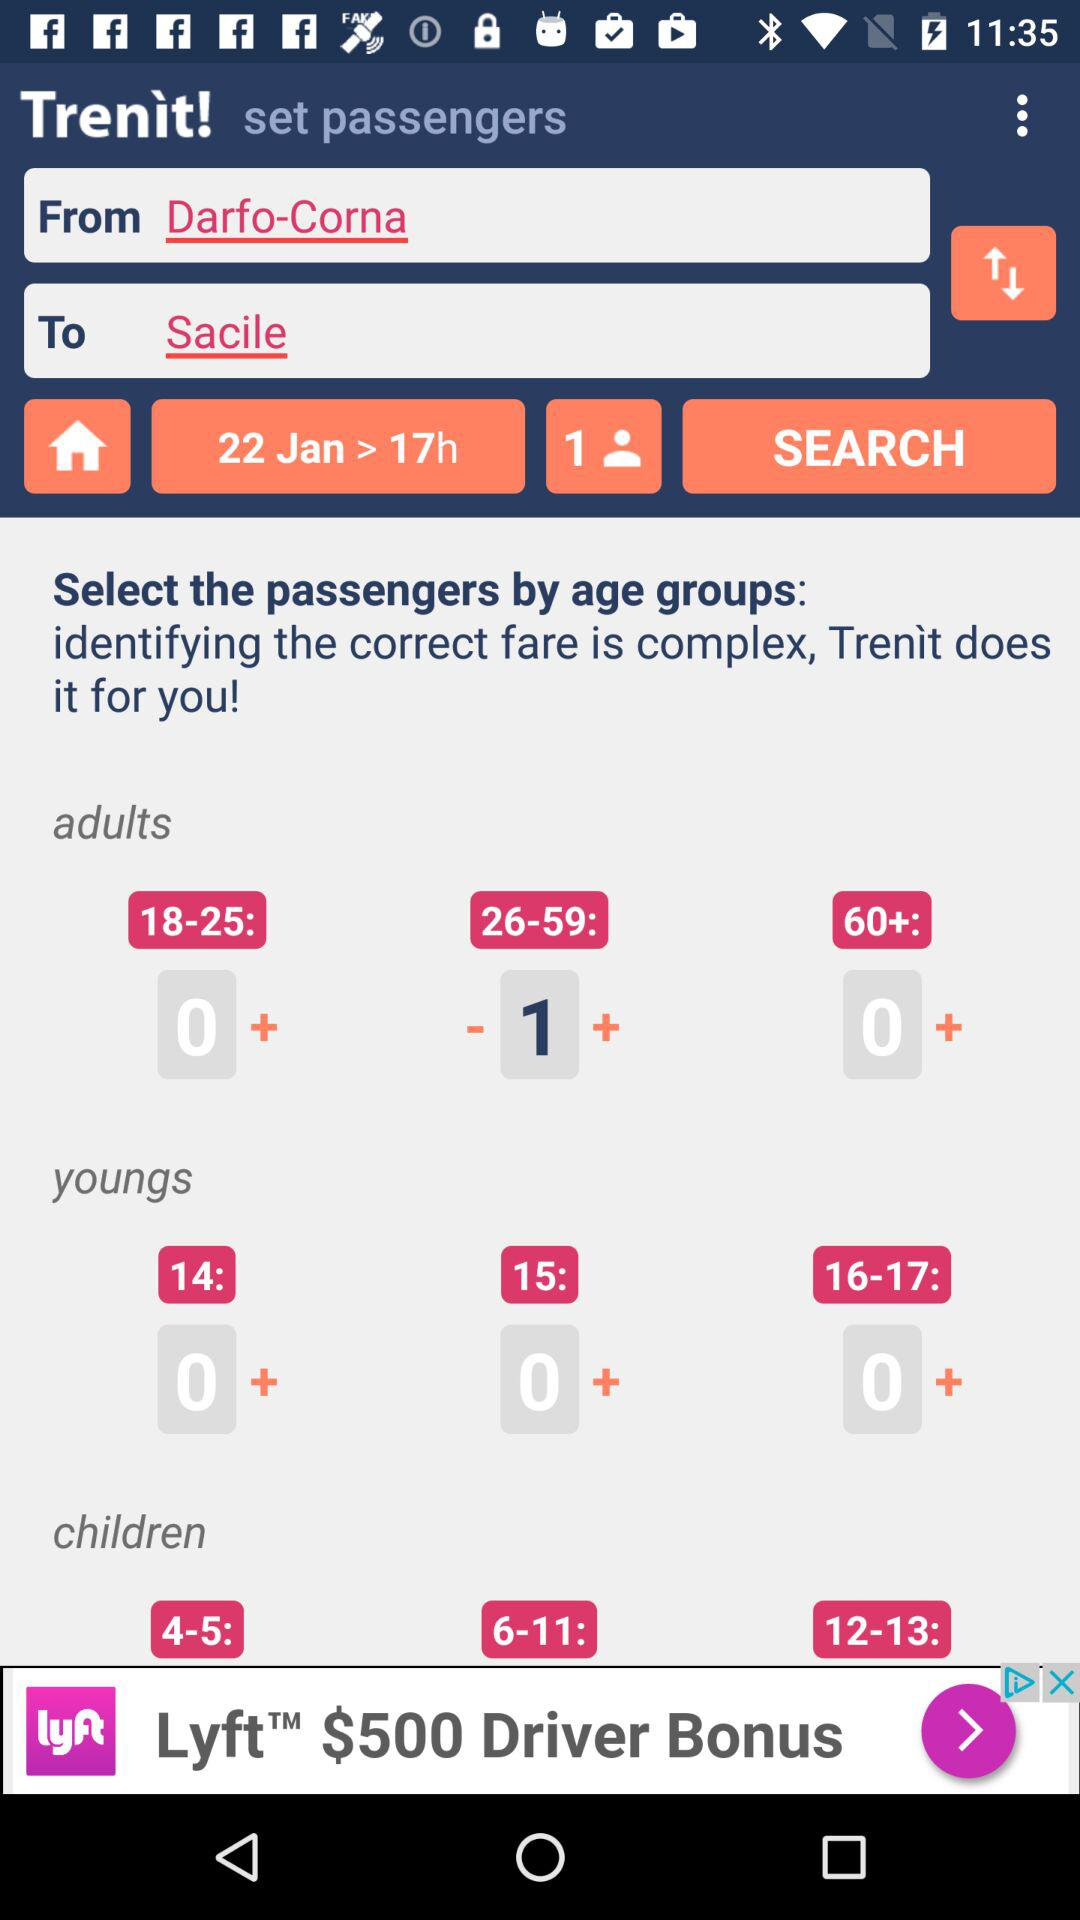What are the age groups given in the children option? The given age groups are 4-5, 6-11 and 12-13. 